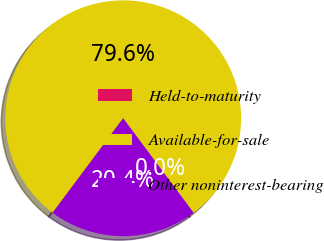<chart> <loc_0><loc_0><loc_500><loc_500><pie_chart><fcel>Held-to-maturity<fcel>Available-for-sale<fcel>Other noninterest-bearing<nl><fcel>0.02%<fcel>79.59%<fcel>20.39%<nl></chart> 